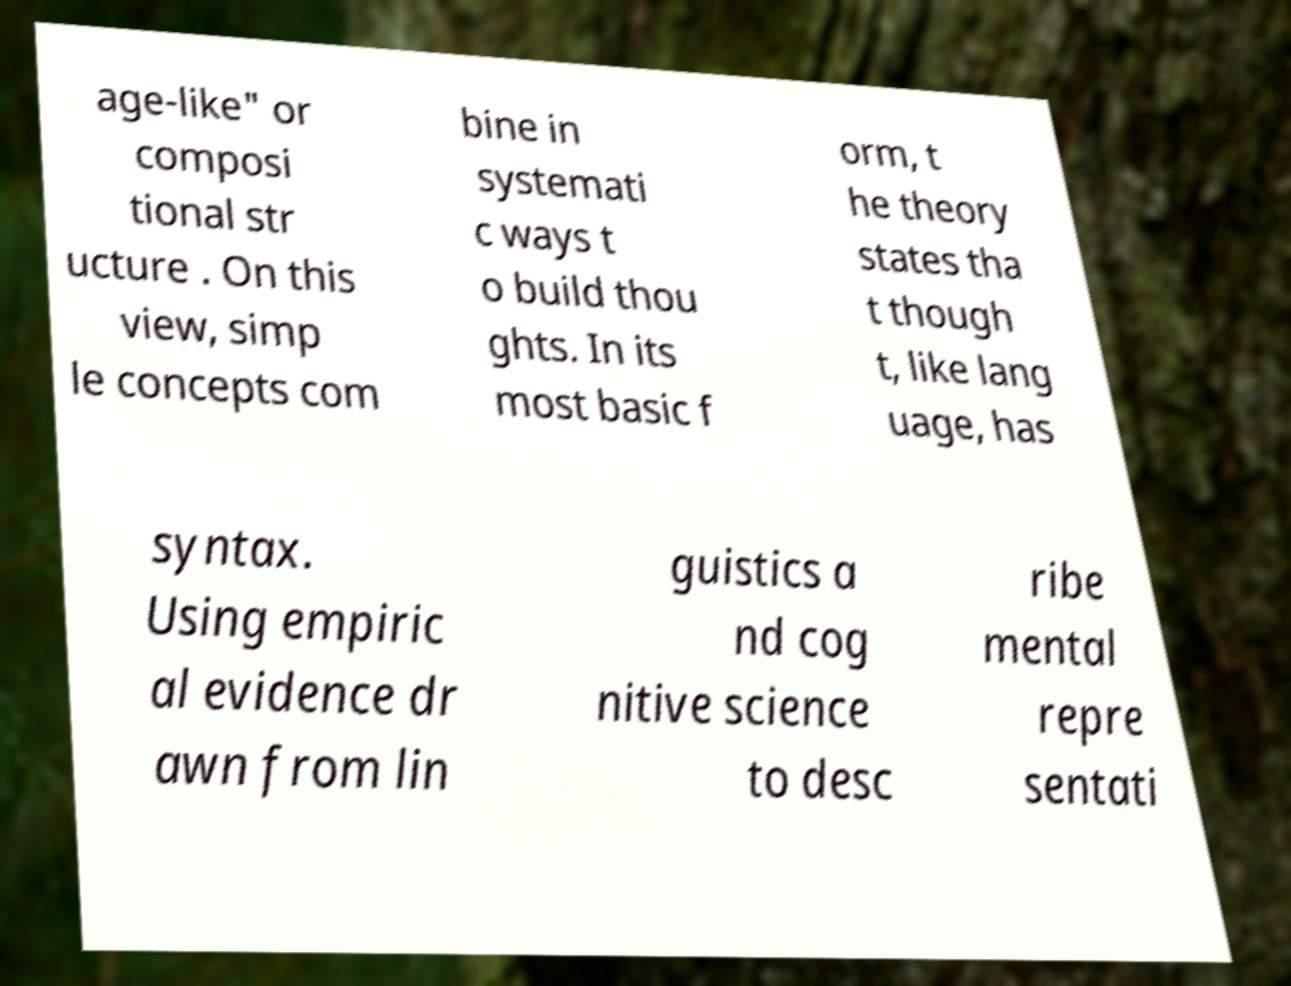Could you extract and type out the text from this image? age-like" or composi tional str ucture . On this view, simp le concepts com bine in systemati c ways t o build thou ghts. In its most basic f orm, t he theory states tha t though t, like lang uage, has syntax. Using empiric al evidence dr awn from lin guistics a nd cog nitive science to desc ribe mental repre sentati 